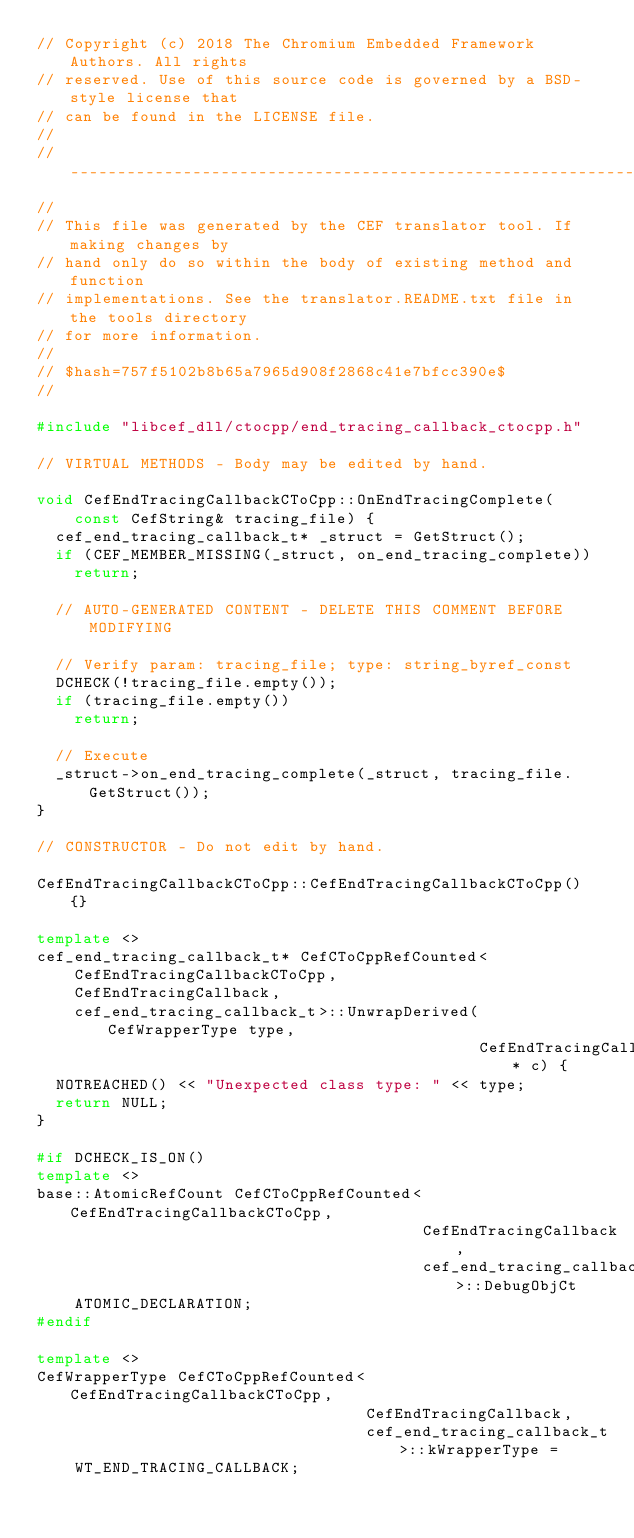Convert code to text. <code><loc_0><loc_0><loc_500><loc_500><_C++_>// Copyright (c) 2018 The Chromium Embedded Framework Authors. All rights
// reserved. Use of this source code is governed by a BSD-style license that
// can be found in the LICENSE file.
//
// ---------------------------------------------------------------------------
//
// This file was generated by the CEF translator tool. If making changes by
// hand only do so within the body of existing method and function
// implementations. See the translator.README.txt file in the tools directory
// for more information.
//
// $hash=757f5102b8b65a7965d908f2868c41e7bfcc390e$
//

#include "libcef_dll/ctocpp/end_tracing_callback_ctocpp.h"

// VIRTUAL METHODS - Body may be edited by hand.

void CefEndTracingCallbackCToCpp::OnEndTracingComplete(
    const CefString& tracing_file) {
  cef_end_tracing_callback_t* _struct = GetStruct();
  if (CEF_MEMBER_MISSING(_struct, on_end_tracing_complete))
    return;

  // AUTO-GENERATED CONTENT - DELETE THIS COMMENT BEFORE MODIFYING

  // Verify param: tracing_file; type: string_byref_const
  DCHECK(!tracing_file.empty());
  if (tracing_file.empty())
    return;

  // Execute
  _struct->on_end_tracing_complete(_struct, tracing_file.GetStruct());
}

// CONSTRUCTOR - Do not edit by hand.

CefEndTracingCallbackCToCpp::CefEndTracingCallbackCToCpp() {}

template <>
cef_end_tracing_callback_t* CefCToCppRefCounted<
    CefEndTracingCallbackCToCpp,
    CefEndTracingCallback,
    cef_end_tracing_callback_t>::UnwrapDerived(CefWrapperType type,
                                               CefEndTracingCallback* c) {
  NOTREACHED() << "Unexpected class type: " << type;
  return NULL;
}

#if DCHECK_IS_ON()
template <>
base::AtomicRefCount CefCToCppRefCounted<CefEndTracingCallbackCToCpp,
                                         CefEndTracingCallback,
                                         cef_end_tracing_callback_t>::DebugObjCt
    ATOMIC_DECLARATION;
#endif

template <>
CefWrapperType CefCToCppRefCounted<CefEndTracingCallbackCToCpp,
                                   CefEndTracingCallback,
                                   cef_end_tracing_callback_t>::kWrapperType =
    WT_END_TRACING_CALLBACK;
</code> 